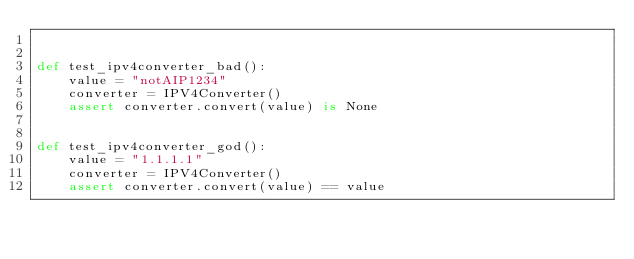<code> <loc_0><loc_0><loc_500><loc_500><_Python_>

def test_ipv4converter_bad():
    value = "notAIP1234"
    converter = IPV4Converter()
    assert converter.convert(value) is None


def test_ipv4converter_god():
    value = "1.1.1.1"
    converter = IPV4Converter()
    assert converter.convert(value) == value
</code> 